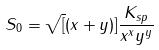<formula> <loc_0><loc_0><loc_500><loc_500>S _ { 0 } = \sqrt { [ } ( x + y ) ] { \frac { K _ { s p } } { x ^ { x } y ^ { y } } }</formula> 